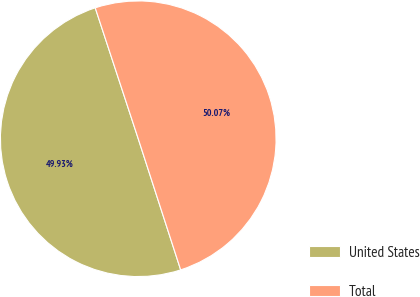<chart> <loc_0><loc_0><loc_500><loc_500><pie_chart><fcel>United States<fcel>Total<nl><fcel>49.93%<fcel>50.07%<nl></chart> 